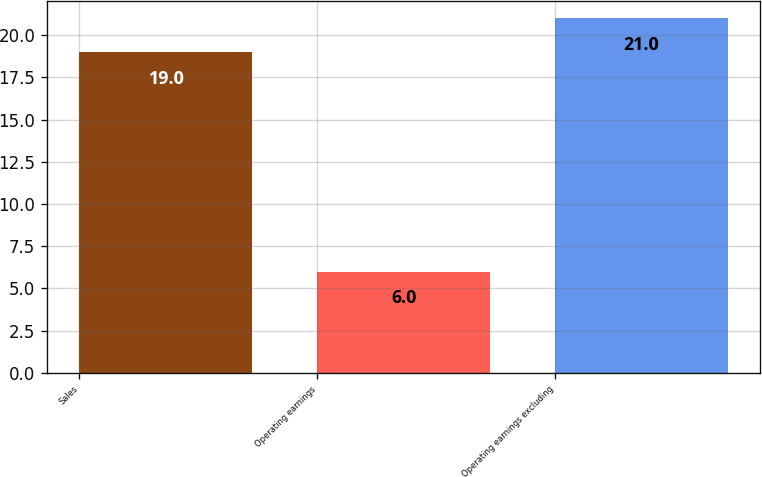Convert chart to OTSL. <chart><loc_0><loc_0><loc_500><loc_500><bar_chart><fcel>Sales<fcel>Operating earnings<fcel>Operating earnings excluding<nl><fcel>19<fcel>6<fcel>21<nl></chart> 